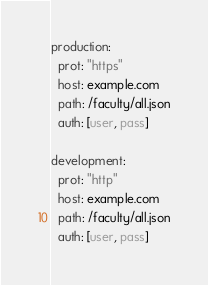Convert code to text. <code><loc_0><loc_0><loc_500><loc_500><_YAML_>production:
  prot: "https"
  host: example.com
  path: /faculty/all.json
  auth: [user, pass]

development:
  prot: "http"
  host: example.com
  path: /faculty/all.json
  auth: [user, pass]
</code> 